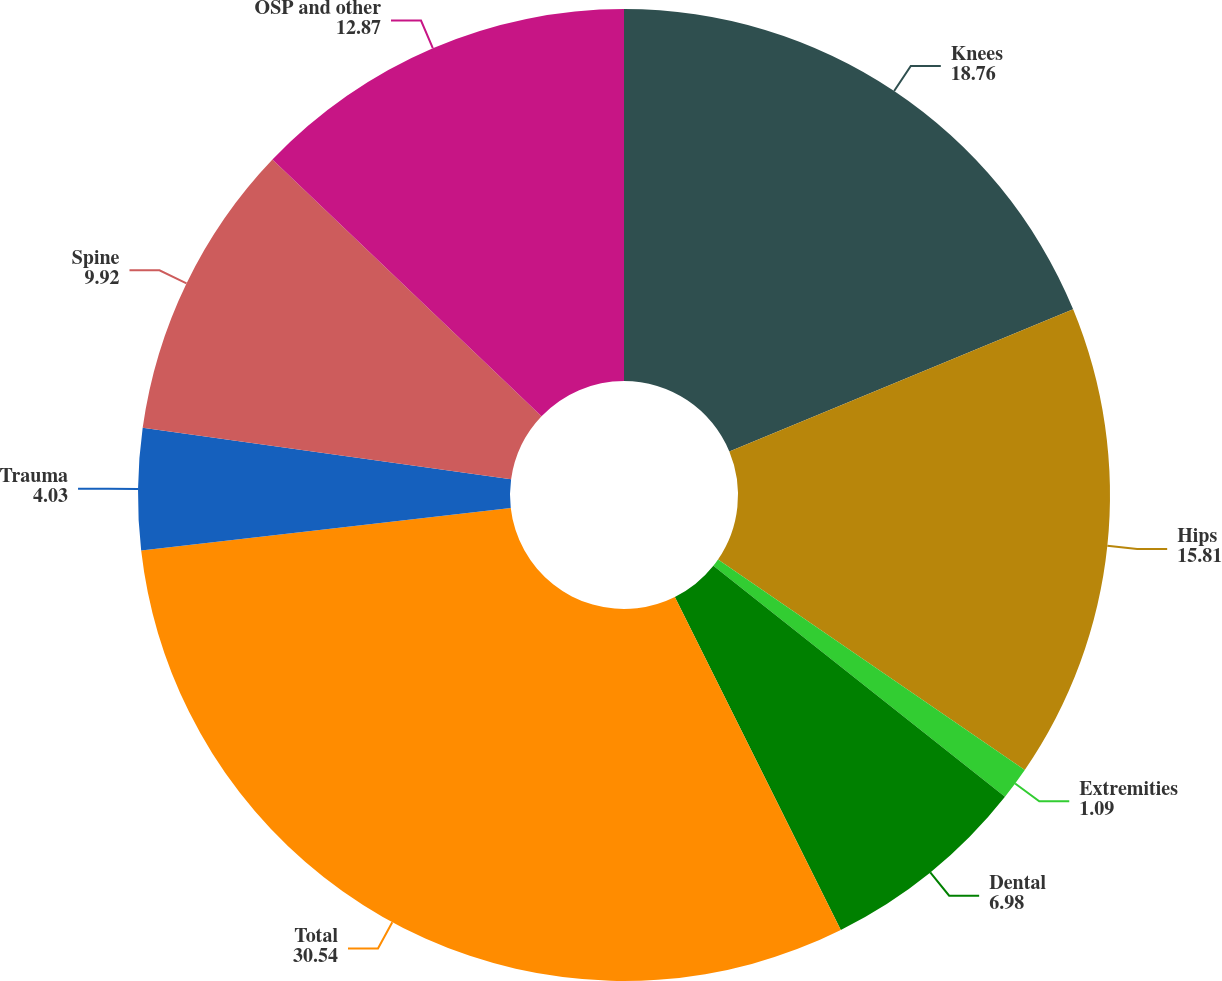Convert chart. <chart><loc_0><loc_0><loc_500><loc_500><pie_chart><fcel>Knees<fcel>Hips<fcel>Extremities<fcel>Dental<fcel>Total<fcel>Trauma<fcel>Spine<fcel>OSP and other<nl><fcel>18.76%<fcel>15.81%<fcel>1.09%<fcel>6.98%<fcel>30.54%<fcel>4.03%<fcel>9.92%<fcel>12.87%<nl></chart> 